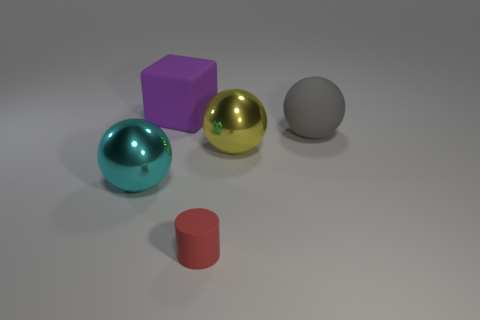Add 1 blue shiny cubes. How many objects exist? 6 Subtract all balls. How many objects are left? 2 Subtract 0 red spheres. How many objects are left? 5 Subtract all small gray cylinders. Subtract all big balls. How many objects are left? 2 Add 5 cyan things. How many cyan things are left? 6 Add 1 blue shiny objects. How many blue shiny objects exist? 1 